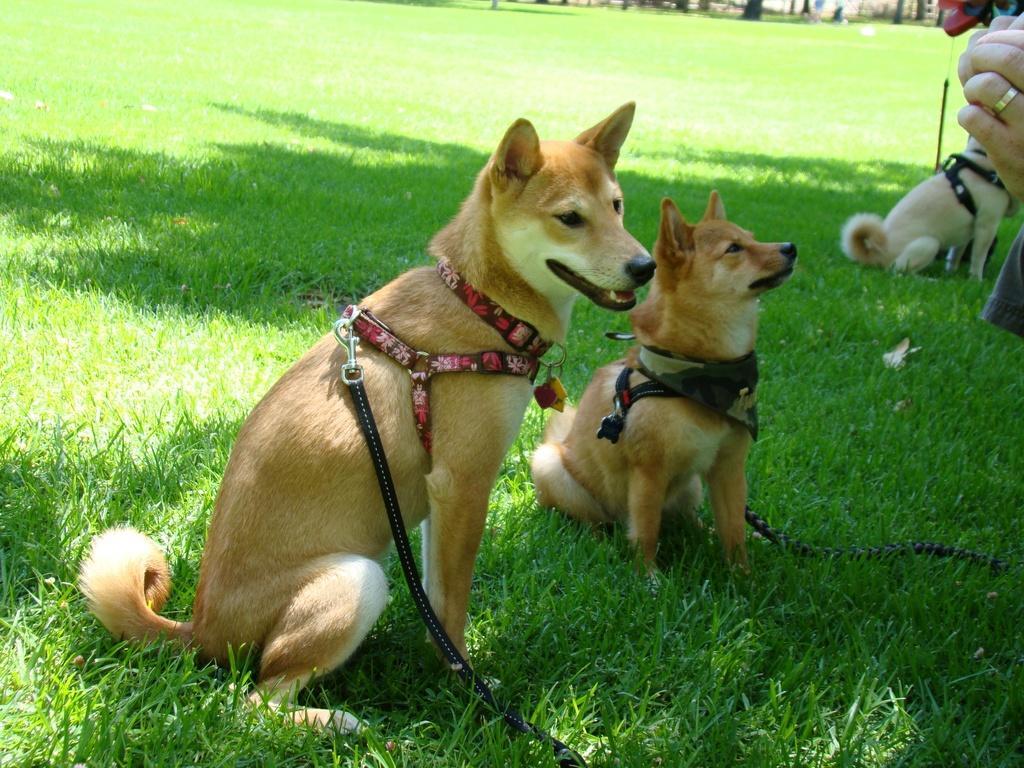Please provide a concise description of this image. In this picture we can see three dogs with belts and a person hand and in the background we can see grass. 